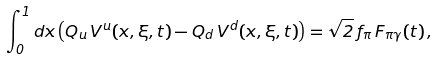<formula> <loc_0><loc_0><loc_500><loc_500>\int ^ { 1 } _ { 0 } d x \left ( Q _ { u } \, V ^ { u } ( x , \xi , t ) - Q _ { d } \, V ^ { d } ( x , \xi , t ) \right ) = \sqrt { 2 } \, f _ { \pi } \, F _ { \pi \gamma } ( t ) \, ,</formula> 